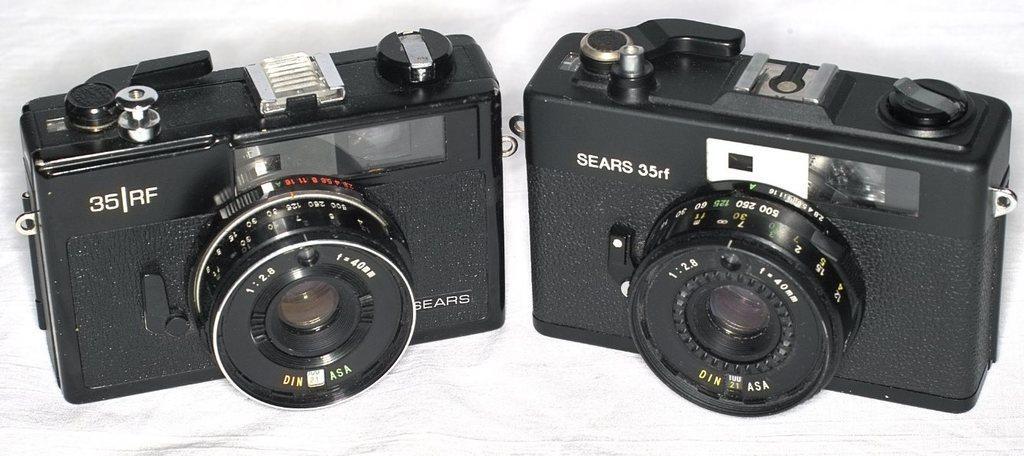How would you summarize this image in a sentence or two? In this image there are cameras. 